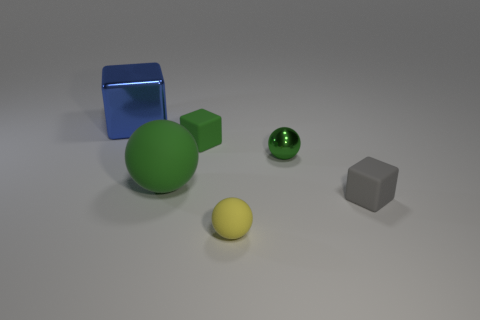Add 2 tiny objects. How many objects exist? 8 Subtract all small balls. How many balls are left? 1 Subtract 2 cubes. How many cubes are left? 1 Add 5 small green balls. How many small green balls exist? 6 Subtract all yellow spheres. How many spheres are left? 2 Subtract 0 gray balls. How many objects are left? 6 Subtract all red spheres. Subtract all red cylinders. How many spheres are left? 3 Subtract all green balls. How many gray blocks are left? 1 Subtract all gray matte cubes. Subtract all small yellow rubber objects. How many objects are left? 4 Add 5 yellow rubber objects. How many yellow rubber objects are left? 6 